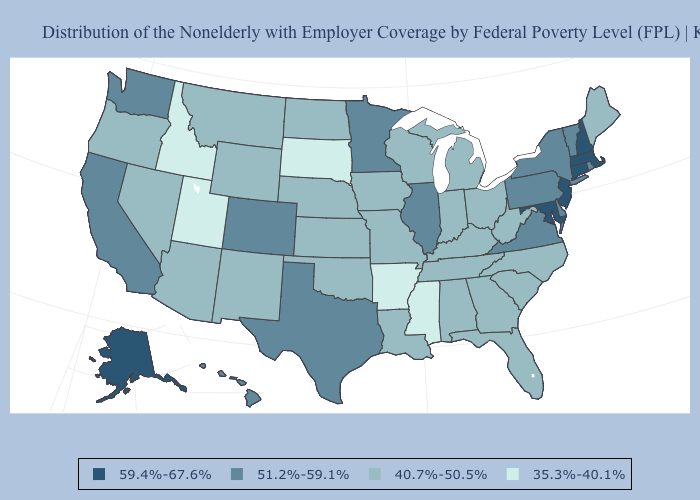Does Utah have the lowest value in the USA?
Keep it brief. Yes. Which states hav the highest value in the Northeast?
Quick response, please. Connecticut, Massachusetts, New Hampshire, New Jersey. Among the states that border Indiana , does Illinois have the highest value?
Be succinct. Yes. What is the lowest value in the MidWest?
Quick response, please. 35.3%-40.1%. Which states have the lowest value in the USA?
Write a very short answer. Arkansas, Idaho, Mississippi, South Dakota, Utah. Name the states that have a value in the range 35.3%-40.1%?
Keep it brief. Arkansas, Idaho, Mississippi, South Dakota, Utah. Does the first symbol in the legend represent the smallest category?
Give a very brief answer. No. Does Tennessee have the same value as North Dakota?
Keep it brief. Yes. Which states have the lowest value in the USA?
Be succinct. Arkansas, Idaho, Mississippi, South Dakota, Utah. Does Nevada have the lowest value in the West?
Be succinct. No. What is the highest value in the West ?
Give a very brief answer. 59.4%-67.6%. Which states hav the highest value in the MidWest?
Give a very brief answer. Illinois, Minnesota. Name the states that have a value in the range 40.7%-50.5%?
Answer briefly. Alabama, Arizona, Florida, Georgia, Indiana, Iowa, Kansas, Kentucky, Louisiana, Maine, Michigan, Missouri, Montana, Nebraska, Nevada, New Mexico, North Carolina, North Dakota, Ohio, Oklahoma, Oregon, South Carolina, Tennessee, West Virginia, Wisconsin, Wyoming. Name the states that have a value in the range 35.3%-40.1%?
Write a very short answer. Arkansas, Idaho, Mississippi, South Dakota, Utah. Among the states that border Rhode Island , which have the lowest value?
Answer briefly. Connecticut, Massachusetts. 